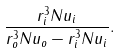<formula> <loc_0><loc_0><loc_500><loc_500>\frac { r ^ { 3 } _ { i } N u _ { i } } { r ^ { 3 } _ { o } N u _ { o } - r ^ { 3 } _ { i } N u _ { i } } .</formula> 